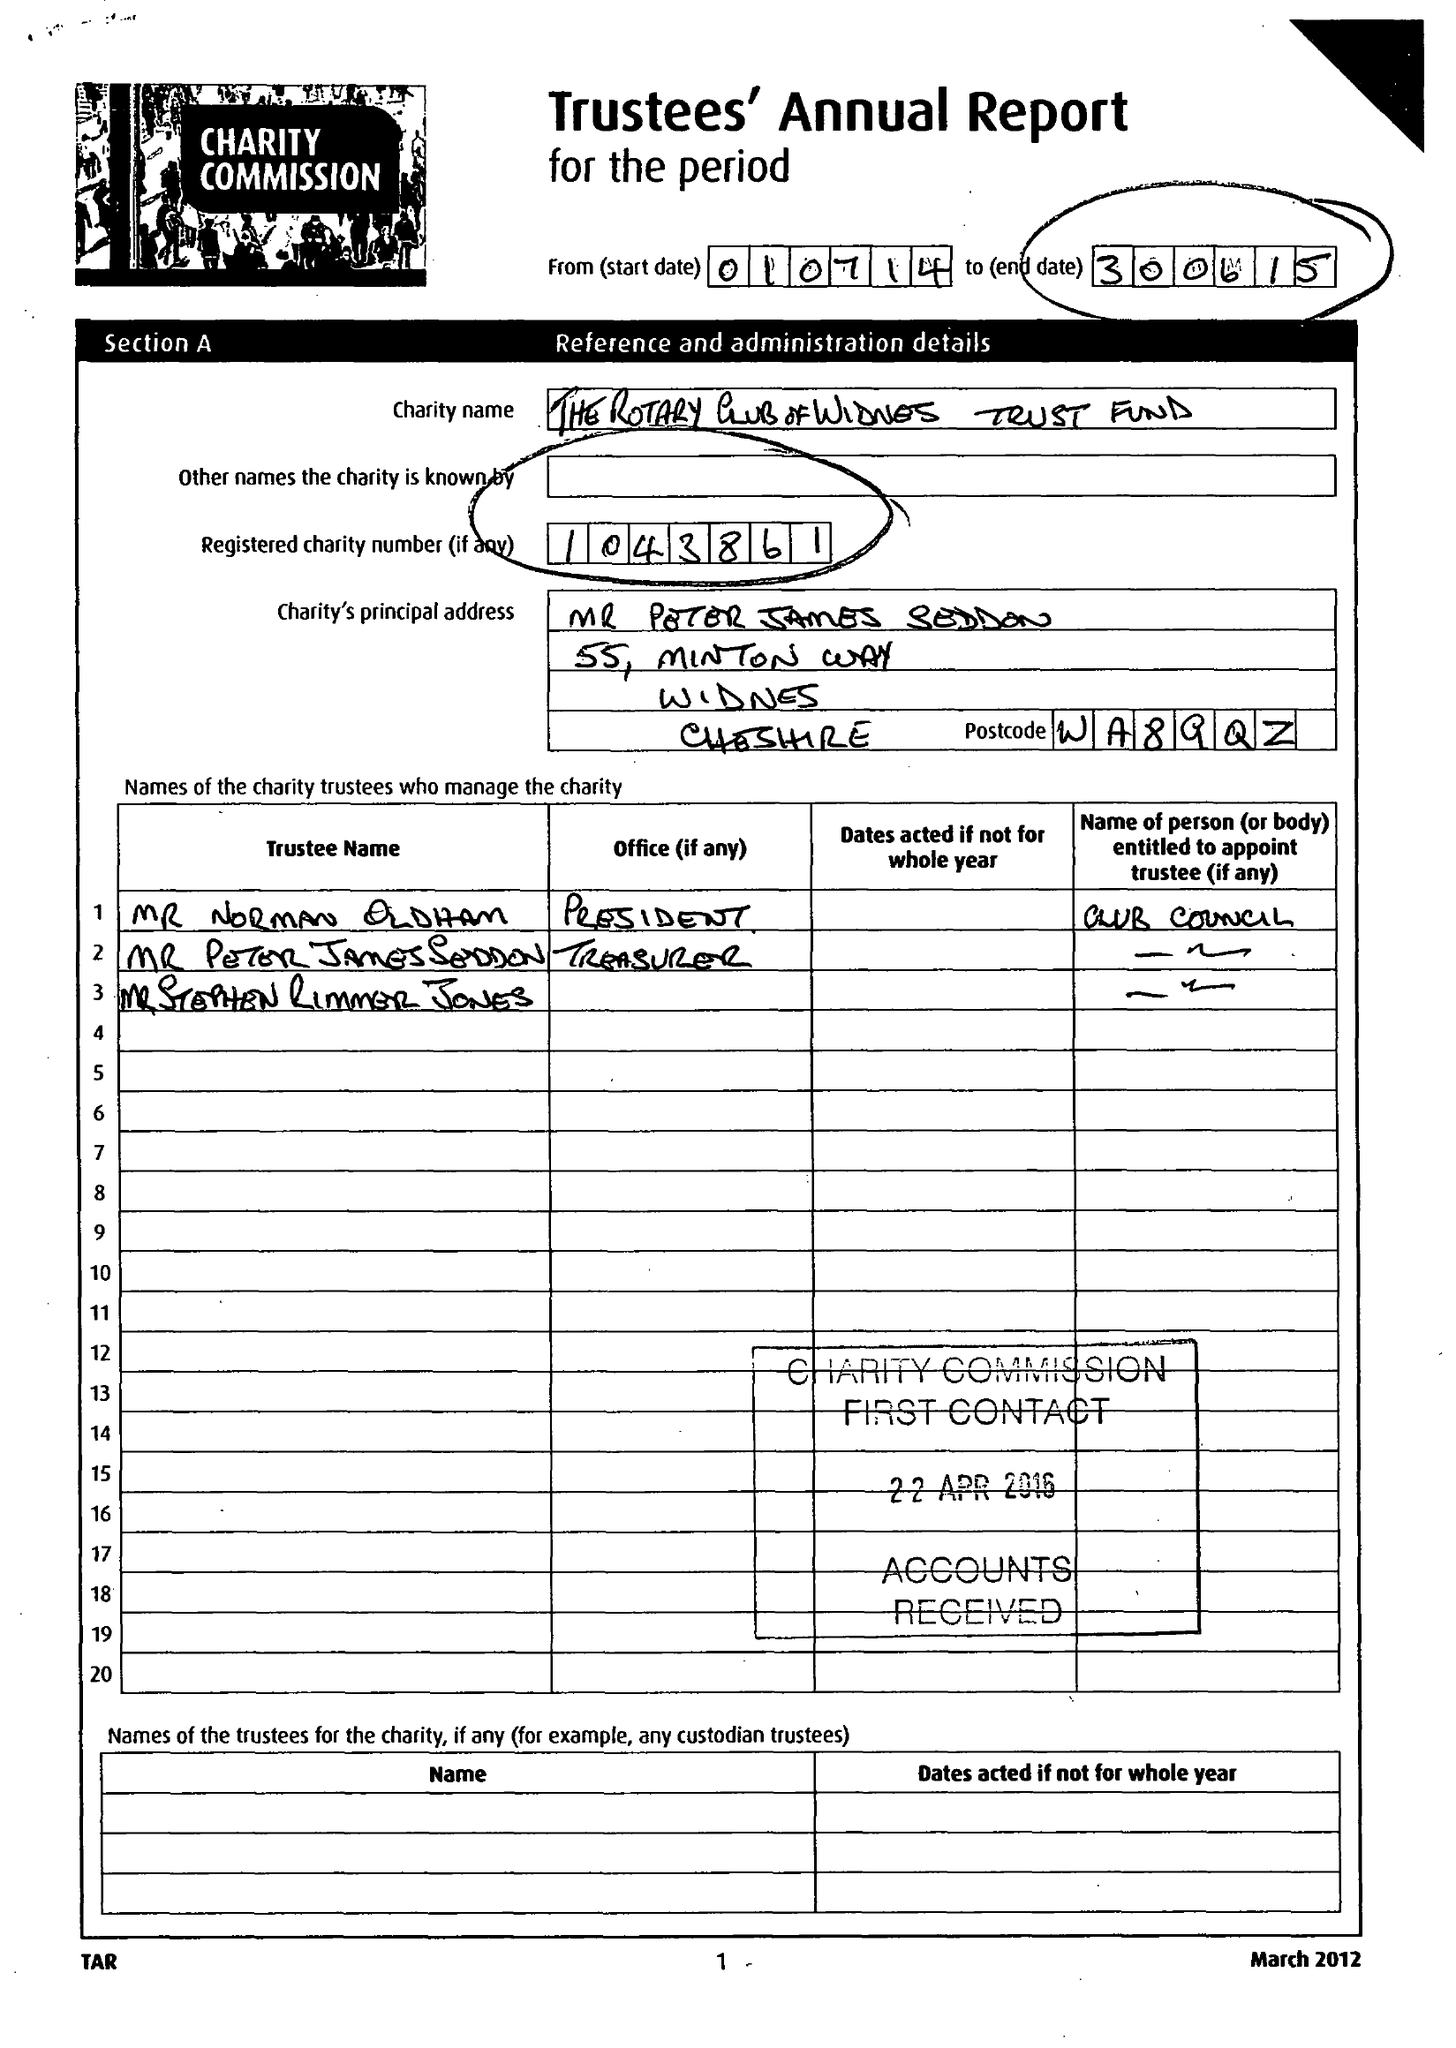What is the value for the charity_name?
Answer the question using a single word or phrase. The Rotary Club Of Widnes Trust Fund 